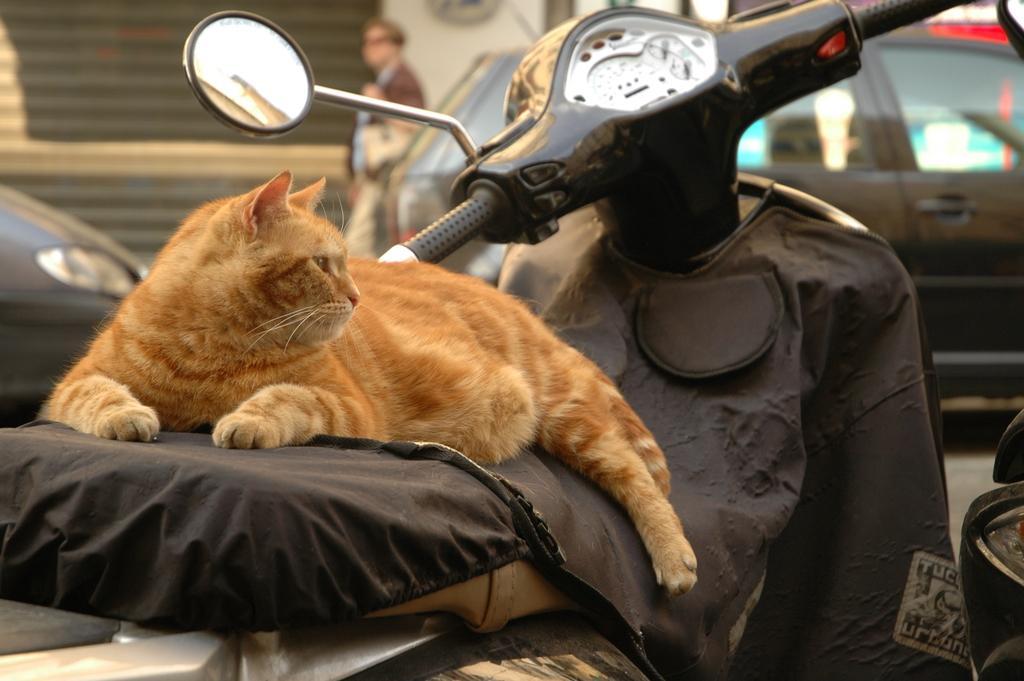Describe this image in one or two sentences. In this picture I can observe a brown color cat sitting on the bike. There is a black color cloth on the bike. I can observe a mirror fixed to the bike. In the background there is a car moving on the road. I can observe a person beside the car. 